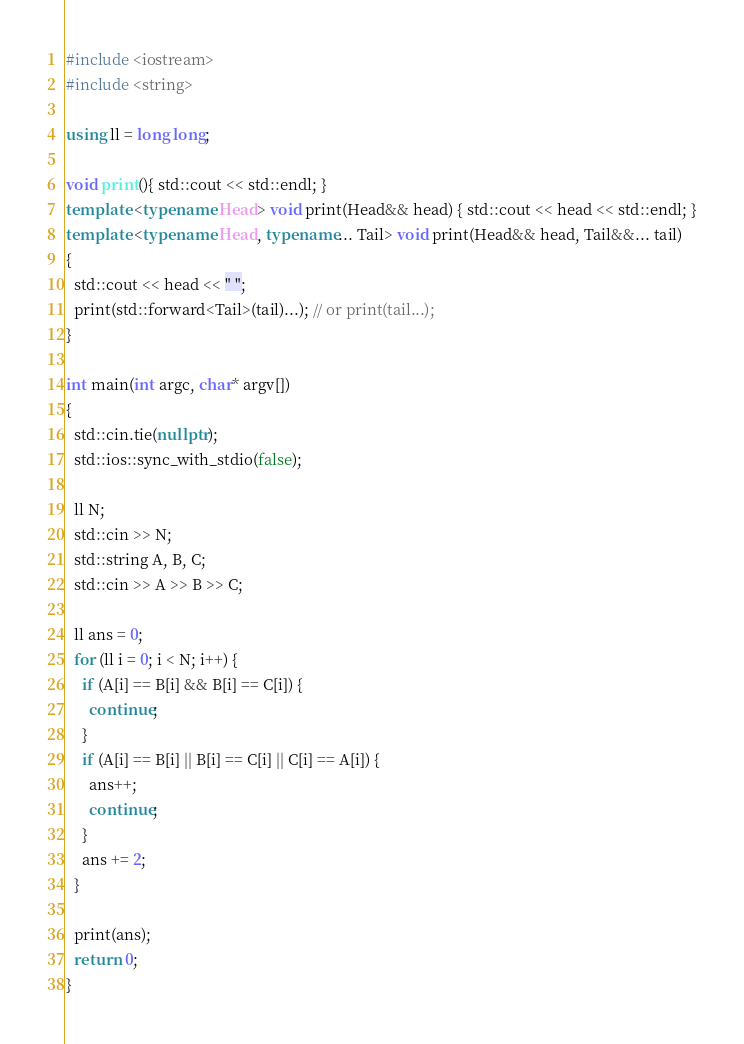Convert code to text. <code><loc_0><loc_0><loc_500><loc_500><_C++_>#include <iostream>
#include <string>

using ll = long long;

void print(){ std::cout << std::endl; }
template <typename Head> void print(Head&& head) { std::cout << head << std::endl; }
template <typename Head, typename... Tail> void print(Head&& head, Tail&&... tail)
{
  std::cout << head << " ";
  print(std::forward<Tail>(tail)...); // or print(tail...);
}

int main(int argc, char* argv[])
{
  std::cin.tie(nullptr);
  std::ios::sync_with_stdio(false);

  ll N;
  std::cin >> N;
  std::string A, B, C;
  std::cin >> A >> B >> C;

  ll ans = 0;
  for (ll i = 0; i < N; i++) {
    if (A[i] == B[i] && B[i] == C[i]) {
      continue;
    }
    if (A[i] == B[i] || B[i] == C[i] || C[i] == A[i]) {
      ans++;
      continue;
    }
    ans += 2;
  }

  print(ans);
  return 0;
}
</code> 